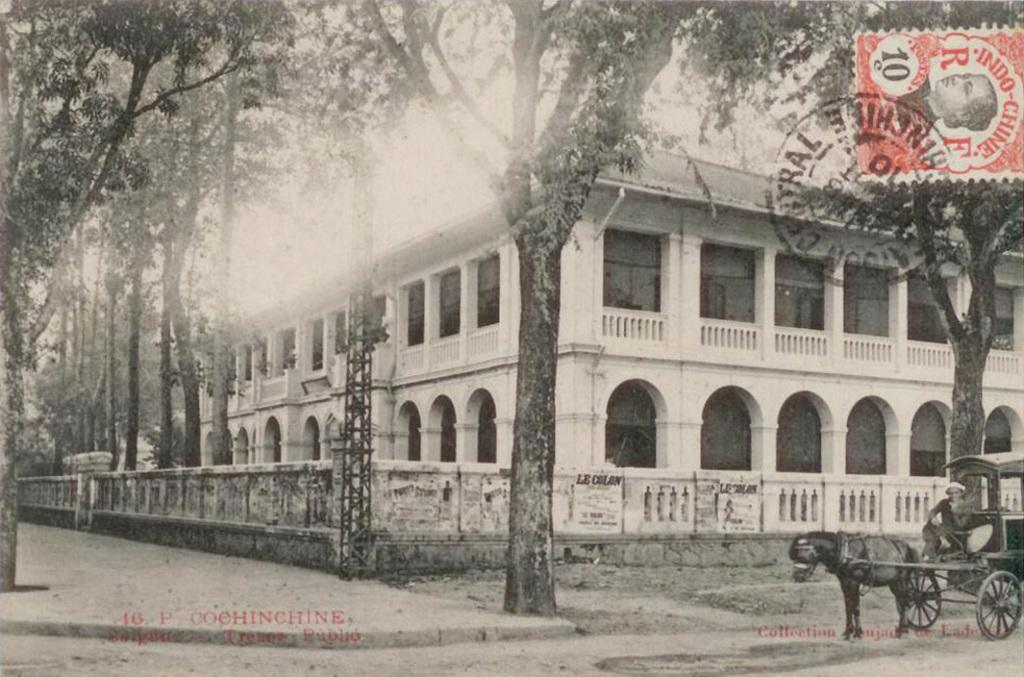What is the color scheme of the image? The image is black and white. What can be seen being pulled by an animal in the image? There is a cart being pulled by an animal in the image. Who is on the cart in the image? There is a person on the cart in the image. What type of vegetation is present in the image? There are trees in the image. What type of structure can be seen in the image? There is a metal tower in the image. What type of building is visible in the image? There is a building in the image. What part of the natural environment is visible in the image? The sky is visible in the image. What type of chalk is being used to draw on the trees in the image? There is no chalk or drawing on the trees in the image. How does the person on the cart provide support to the animal pulling it in the image? The person on the cart is not providing support to the animal pulling it in the image; they are simply riding on the cart. 